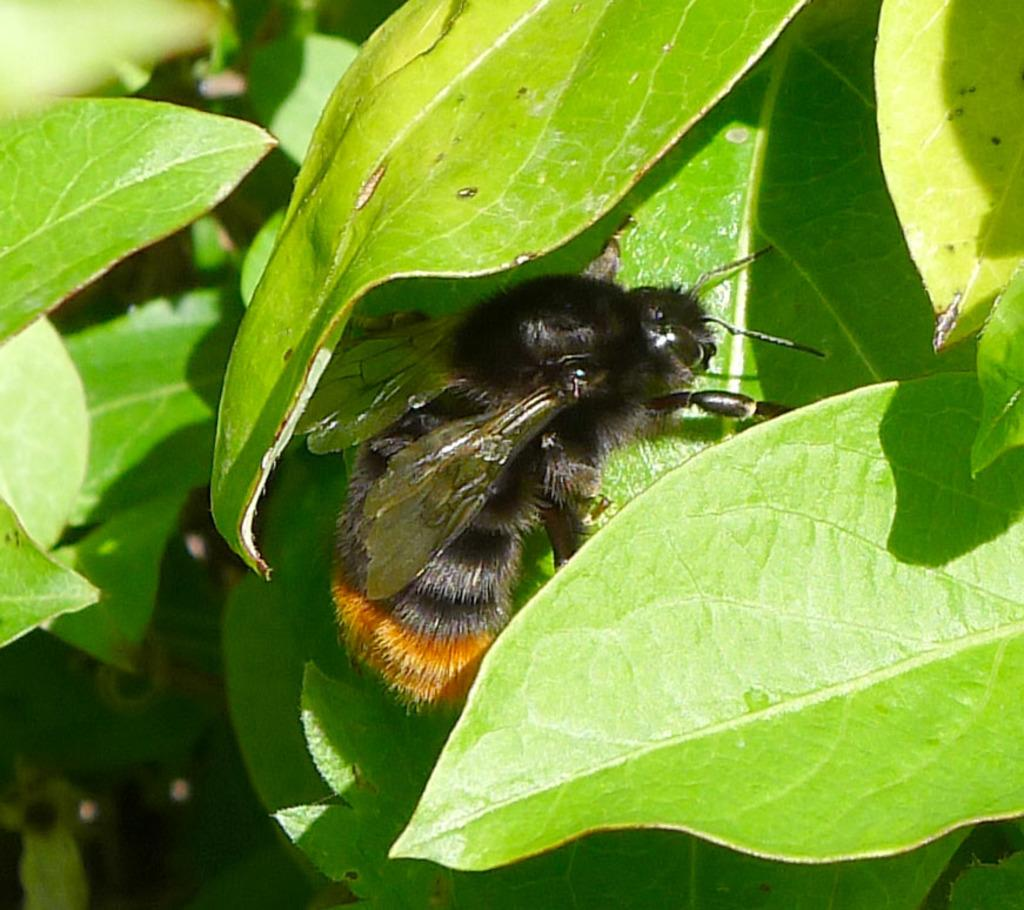What is present on the leaf in the image? There is an insect on a leaf in the image. What type of plant is visible in the image? The leaves of a plant are visible in the image. What type of blood can be seen on the insect in the image? There is no blood visible on the insect in the image. What level of detail can be seen on the insect in the image? The level of detail on the insect cannot be determined from the image alone, as it depends on the quality of the image and the observer's ability to discern details. 